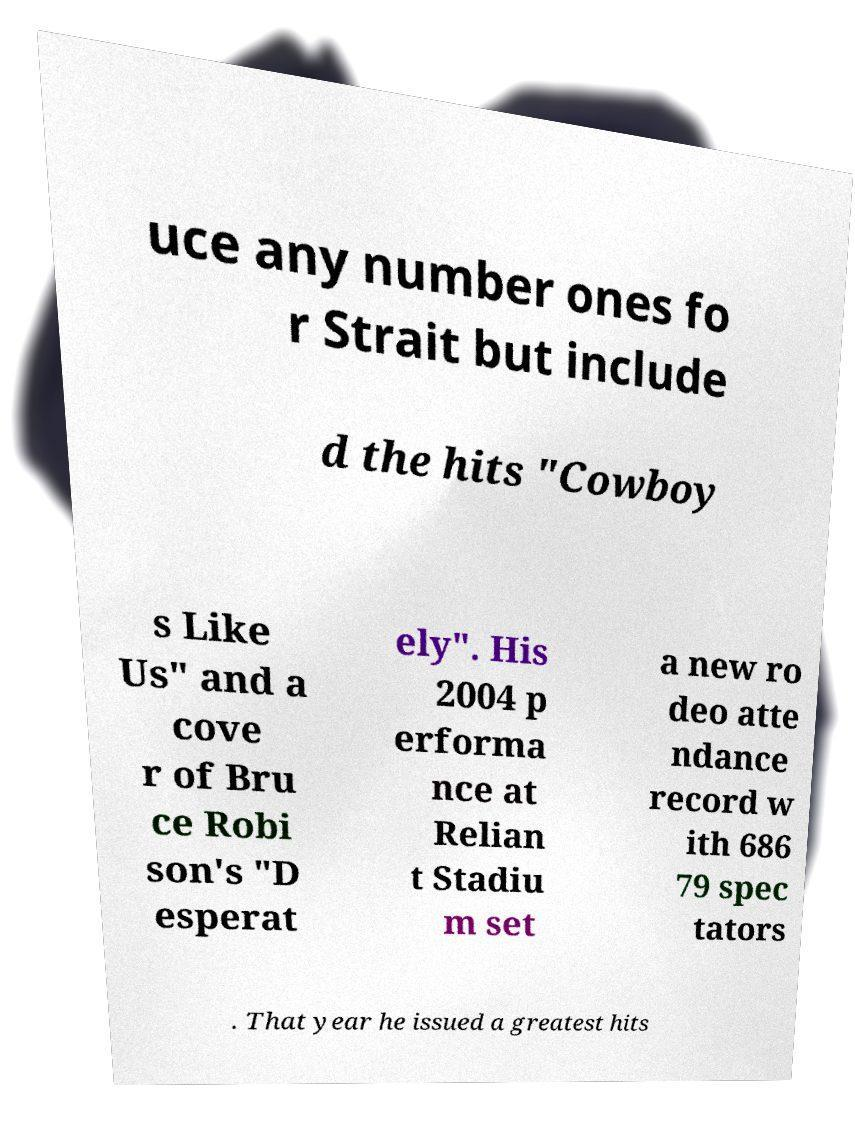For documentation purposes, I need the text within this image transcribed. Could you provide that? uce any number ones fo r Strait but include d the hits "Cowboy s Like Us" and a cove r of Bru ce Robi son's "D esperat ely". His 2004 p erforma nce at Relian t Stadiu m set a new ro deo atte ndance record w ith 686 79 spec tators . That year he issued a greatest hits 